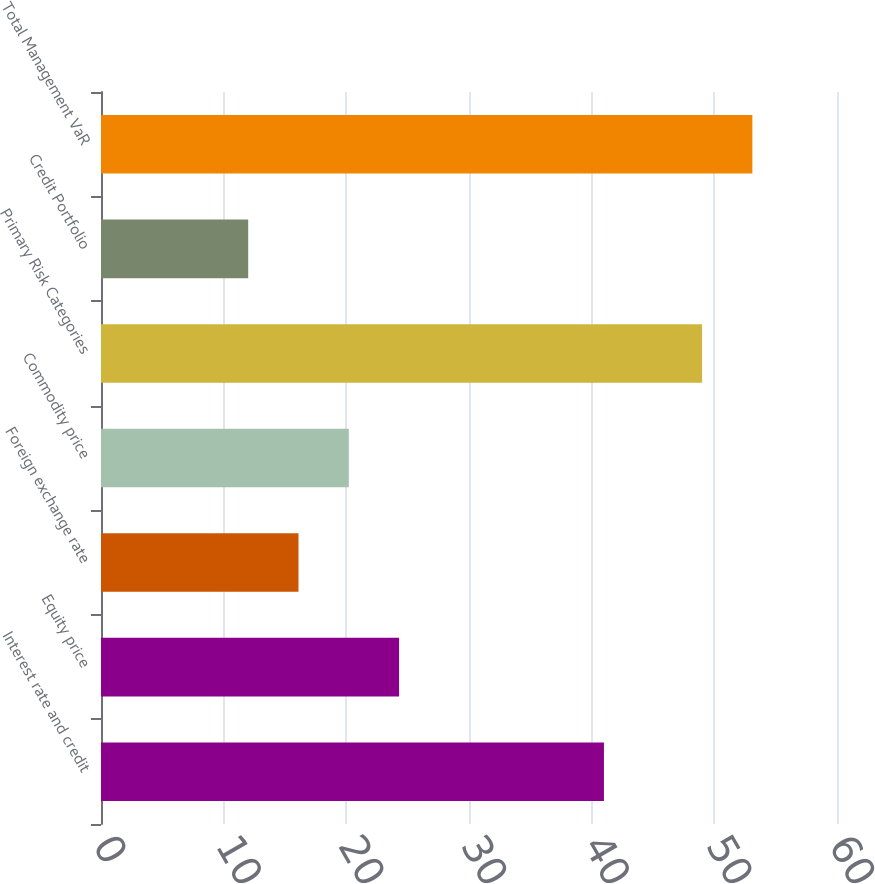Convert chart to OTSL. <chart><loc_0><loc_0><loc_500><loc_500><bar_chart><fcel>Interest rate and credit<fcel>Equity price<fcel>Foreign exchange rate<fcel>Commodity price<fcel>Primary Risk Categories<fcel>Credit Portfolio<fcel>Total Management VaR<nl><fcel>41<fcel>24.3<fcel>16.1<fcel>20.2<fcel>49<fcel>12<fcel>53.1<nl></chart> 